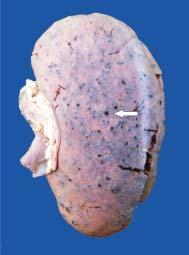s epra bacilli in ll seen in fite-faraco enlarged in size and weight?
Answer the question using a single word or phrase. No 